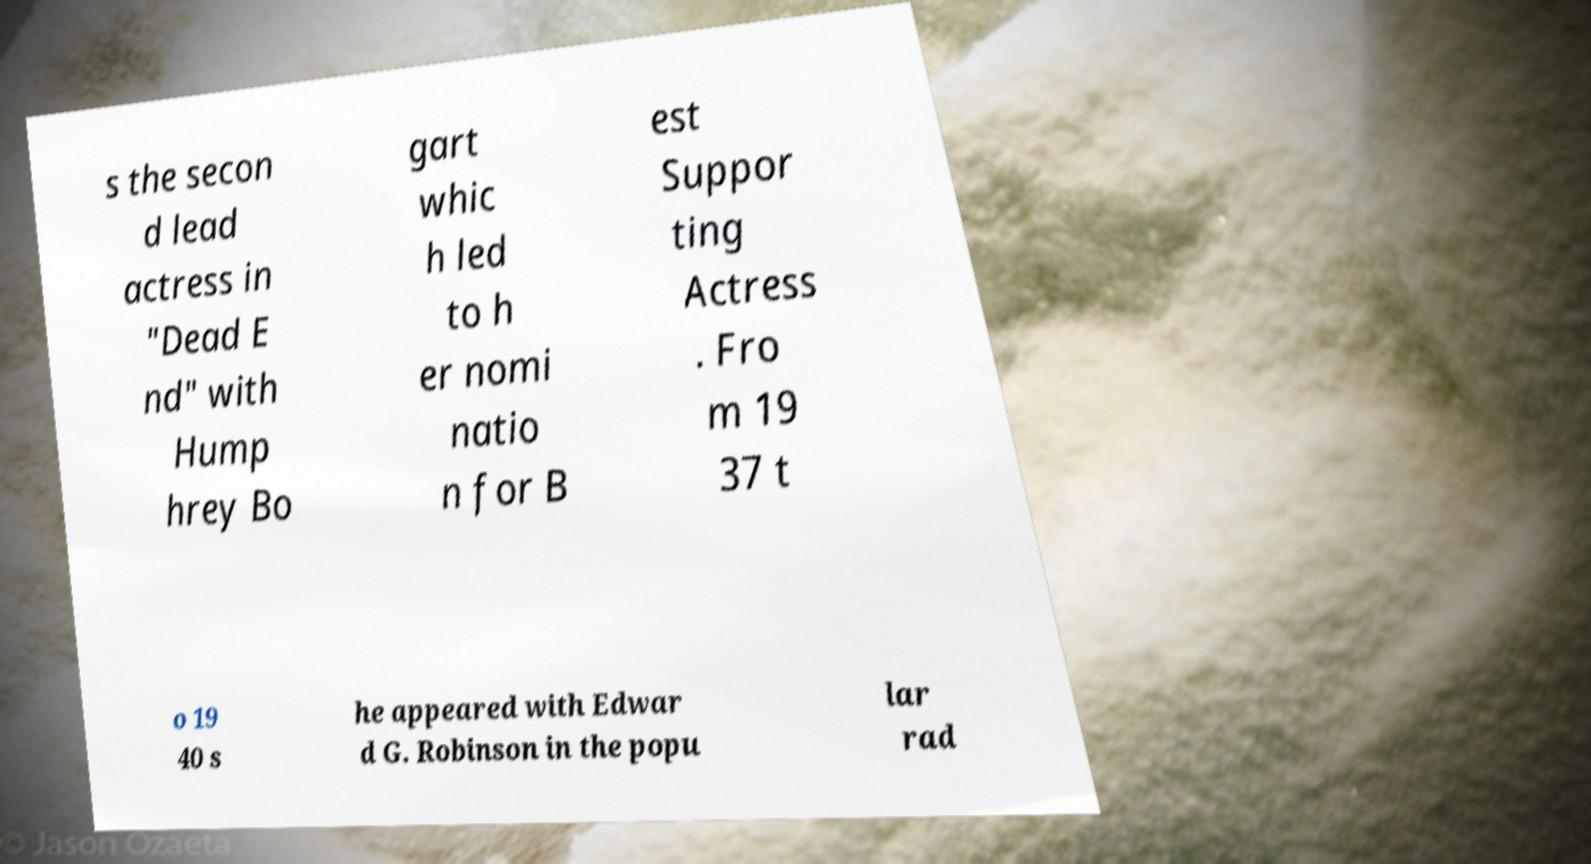Please identify and transcribe the text found in this image. s the secon d lead actress in "Dead E nd" with Hump hrey Bo gart whic h led to h er nomi natio n for B est Suppor ting Actress . Fro m 19 37 t o 19 40 s he appeared with Edwar d G. Robinson in the popu lar rad 